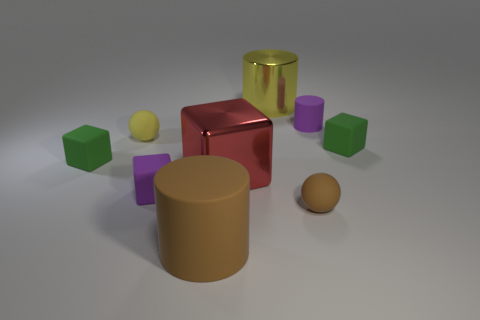Are there any patterns or similarities among the objects in the image? Yes, there are patterns concerning shape and color. There are three pairs of objects sharing the same color: yellow cylinder and cube, green cubes, and purple cubes. Each pair has different sizes, and the shapes include cylinders, cubes, and a sphere.  What can you infer about the light source in this image? Based on the shadows cast by the objects and the light reflecting off of their surfaces, it appears that the light source is coming from the upper left side of the image. The shadows are soft and diffused, suggesting an indirect or ambient light source. 